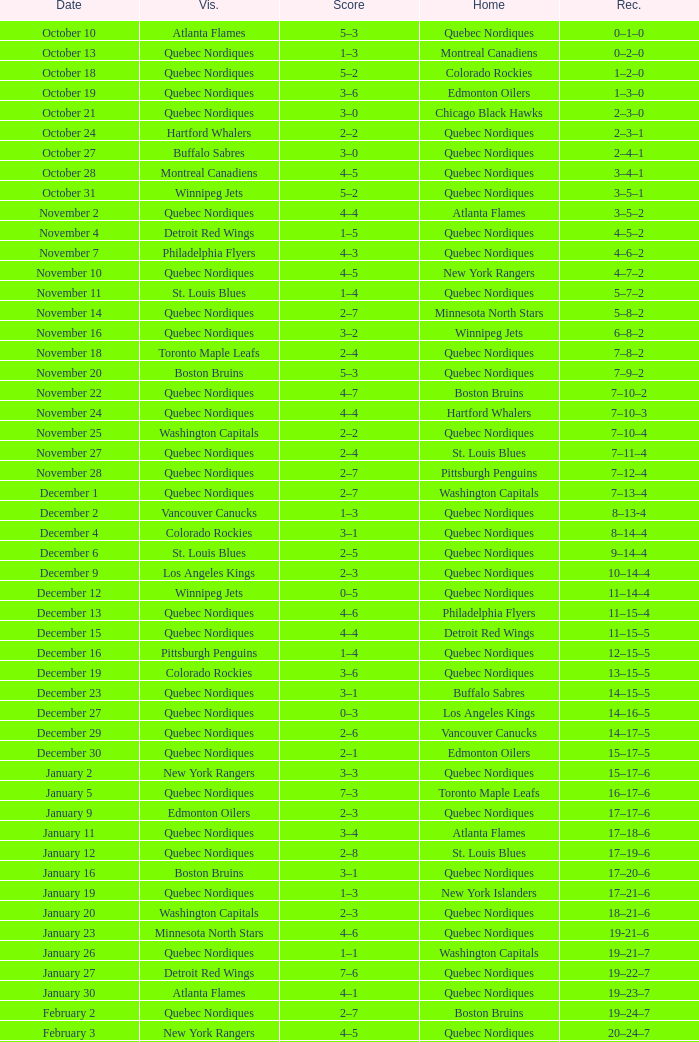Which Home has a Record of 11–14–4? Quebec Nordiques. 